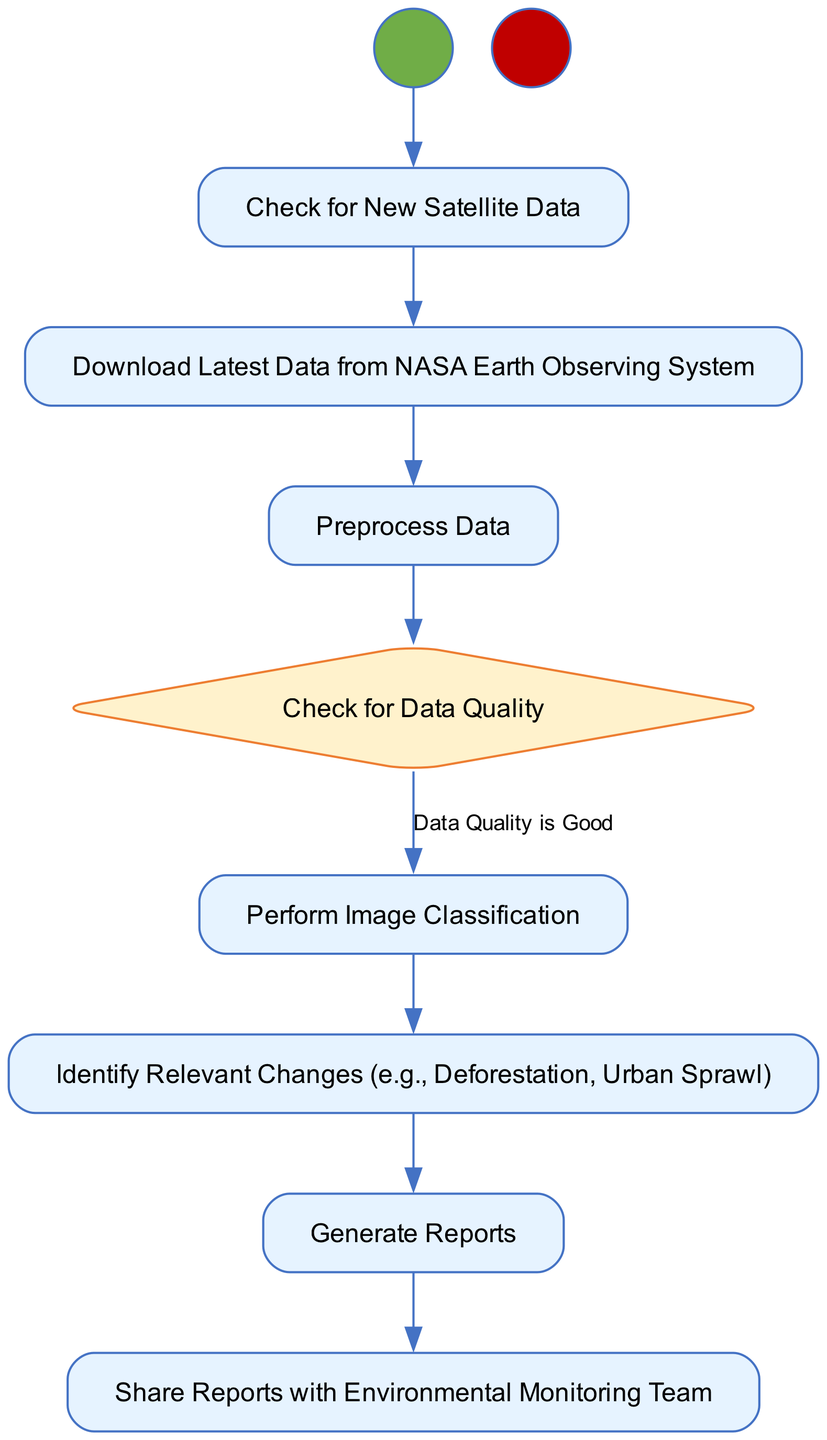What is the first activity in the diagram? The first activity in the diagram is represented by the "Start" node, which indicates the beginning of the routine.
Answer: Start How many decision points are there in the diagram? There is one decision point in the diagram, which checks for data quality.
Answer: 1 What happens if the data quality is poor? If the data quality is poor, the next step will be to notify the supervisor and end the process.
Answer: Notify Supervisor and End Which activity comes after "Preprocess Data"? The activity that comes after "Preprocess Data" is the decision point checking for data quality.
Answer: Check for Data Quality How many reports are generated in this routine? Only one report is generated in this routine as indicated by the activity "Generate Reports."
Answer: 1 What is the last event in the diagram? The last event in the diagram is represented by the "End" node, indicating the conclusion of the routine.
Answer: End Which activities lead to "Share Reports with Environmental Monitoring Team"? The activities leading to "Share Reports with Environmental Monitoring Team" are "Generate Reports."
Answer: Generate Reports If the data quality is good, what is the next activity? If the data quality is good, the next activity is "Perform Image Classification."
Answer: Perform Image Classification What change is identified after performing image classification? After performing image classification, the relevant changes identified include deforestation and urban sprawl.
Answer: Identify Relevant Changes (e.g., Deforestation, Urban Sprawl) 